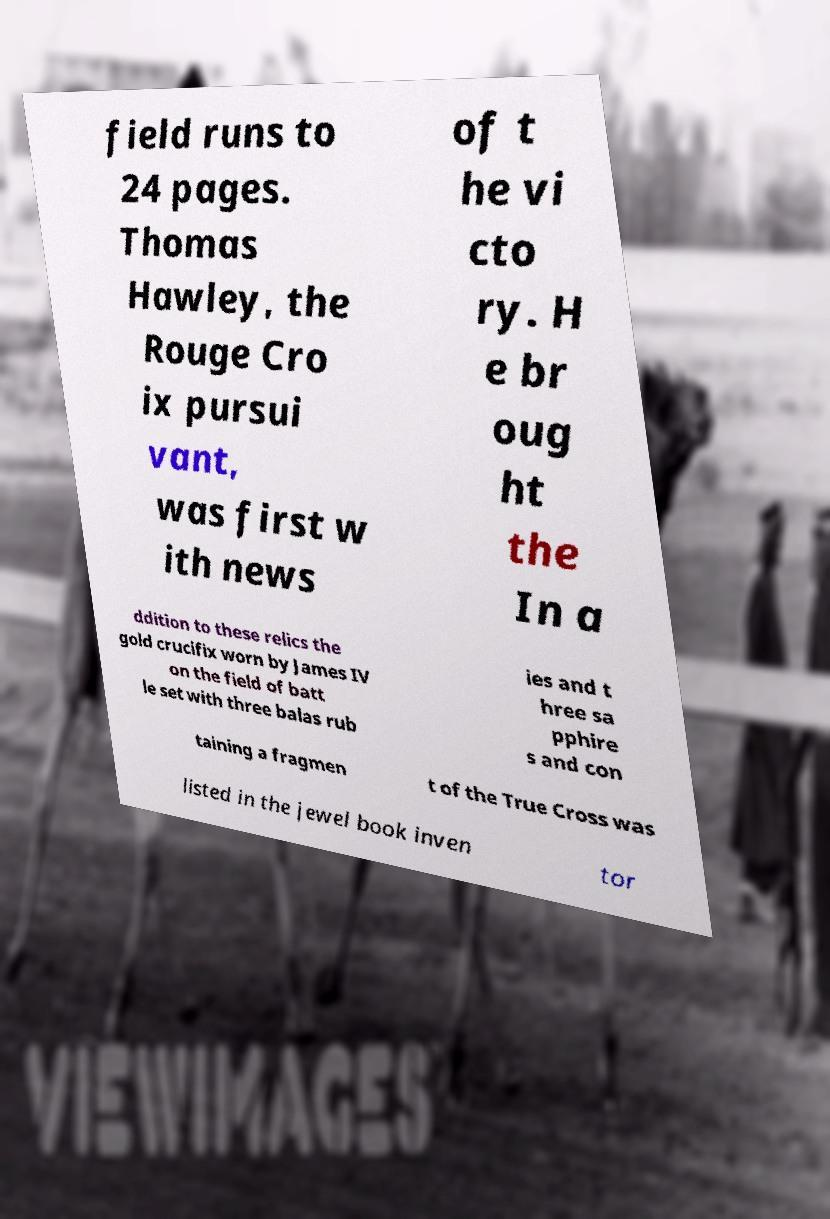Could you extract and type out the text from this image? field runs to 24 pages. Thomas Hawley, the Rouge Cro ix pursui vant, was first w ith news of t he vi cto ry. H e br oug ht the In a ddition to these relics the gold crucifix worn by James IV on the field of batt le set with three balas rub ies and t hree sa pphire s and con taining a fragmen t of the True Cross was listed in the jewel book inven tor 